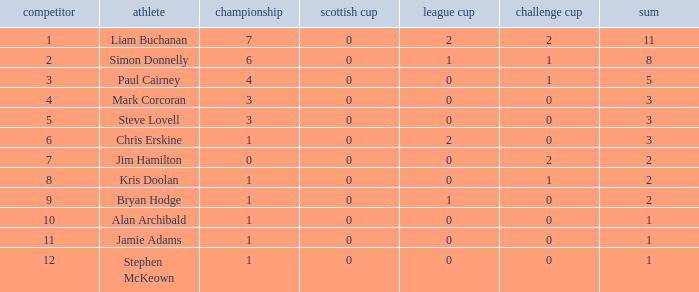What is bryan hodge's player number 1.0. 